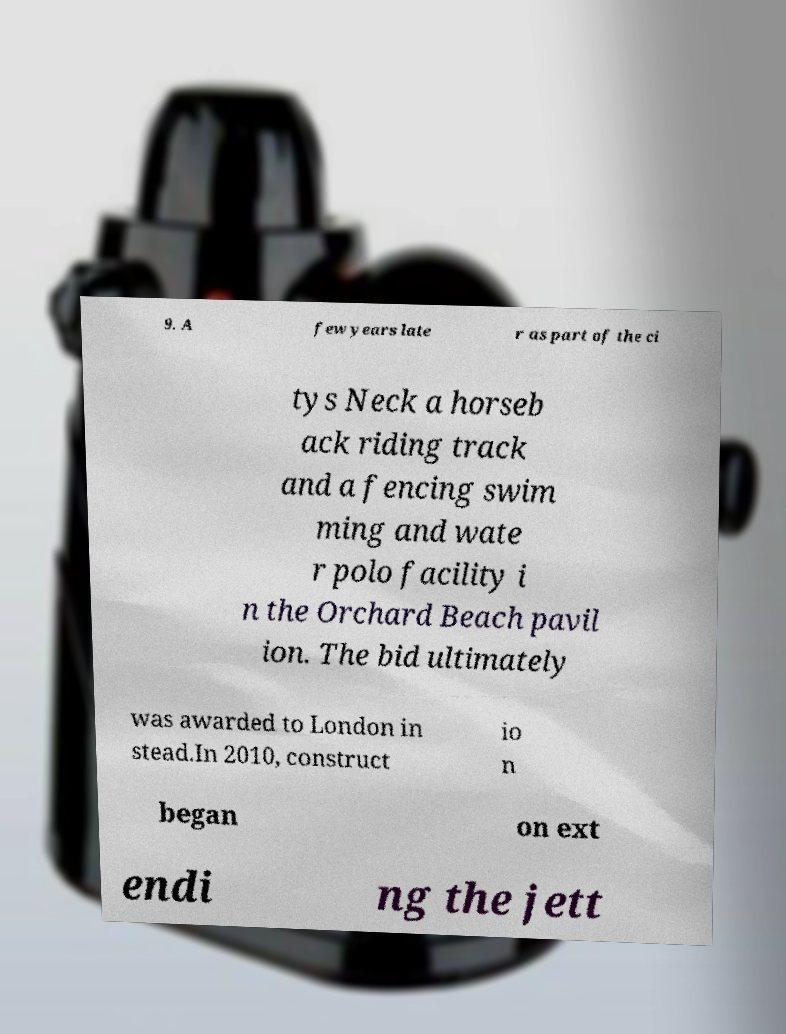I need the written content from this picture converted into text. Can you do that? 9. A few years late r as part of the ci tys Neck a horseb ack riding track and a fencing swim ming and wate r polo facility i n the Orchard Beach pavil ion. The bid ultimately was awarded to London in stead.In 2010, construct io n began on ext endi ng the jett 